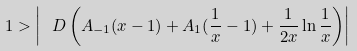Convert formula to latex. <formula><loc_0><loc_0><loc_500><loc_500>1 > \left | \ D \left ( A _ { - 1 } ( x - 1 ) + A _ { 1 } ( \frac { 1 } { x } - 1 ) + \frac { 1 } { 2 x } \ln \frac { 1 } { x } \right ) \right |</formula> 